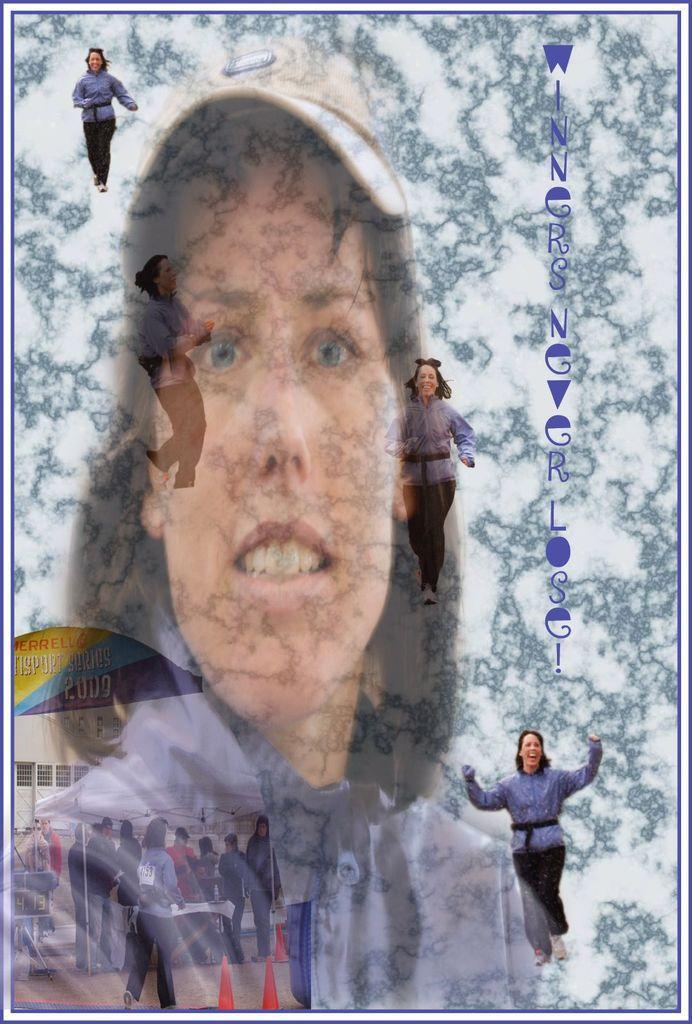Could you give a brief overview of what you see in this image? This is an edited image. At the bottom left side of the image, I can see a group of people, steal, traffic cones and a table with few objects. In the background, I can see the picture of a woman and the letters. 